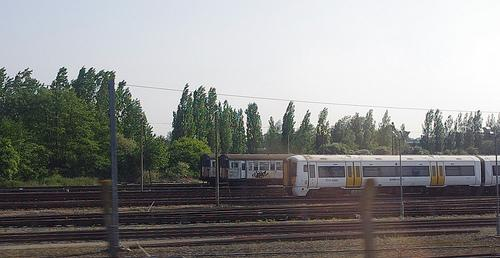Question: how many trains are shown?
Choices:
A. 3.
B. 12.
C. 13.
D. 5.
Answer with the letter. Answer: A Question: what color is the train nearest the camera?
Choices:
A. Teal.
B. Purple.
C. Neon.
D. White.
Answer with the letter. Answer: D 